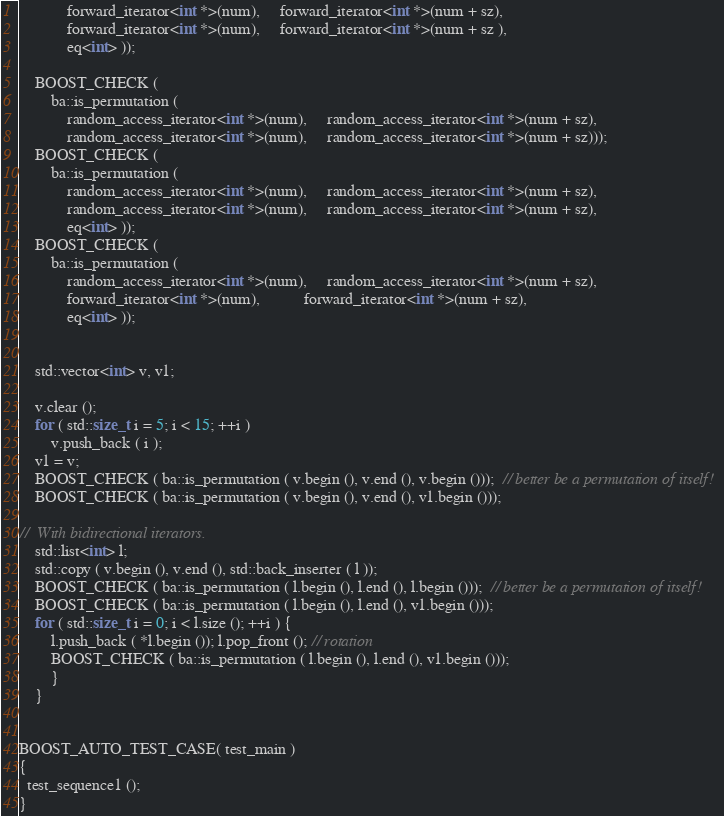Convert code to text. <code><loc_0><loc_0><loc_500><loc_500><_C++_>            forward_iterator<int *>(num),     forward_iterator<int *>(num + sz), 
            forward_iterator<int *>(num),     forward_iterator<int *>(num + sz ),
            eq<int> ));
            
    BOOST_CHECK (
        ba::is_permutation (
            random_access_iterator<int *>(num),     random_access_iterator<int *>(num + sz), 
            random_access_iterator<int *>(num),     random_access_iterator<int *>(num + sz)));
    BOOST_CHECK (
        ba::is_permutation (
            random_access_iterator<int *>(num),     random_access_iterator<int *>(num + sz), 
            random_access_iterator<int *>(num),     random_access_iterator<int *>(num + sz),
            eq<int> ));
    BOOST_CHECK (
        ba::is_permutation (
            random_access_iterator<int *>(num),     random_access_iterator<int *>(num + sz), 
            forward_iterator<int *>(num),           forward_iterator<int *>(num + sz),
            eq<int> ));
    

    std::vector<int> v, v1;
    
    v.clear ();
    for ( std::size_t i = 5; i < 15; ++i )
        v.push_back ( i );
    v1 = v;
    BOOST_CHECK ( ba::is_permutation ( v.begin (), v.end (), v.begin ()));  // better be a permutation of itself!
    BOOST_CHECK ( ba::is_permutation ( v.begin (), v.end (), v1.begin ()));    

//  With bidirectional iterators.
    std::list<int> l;
    std::copy ( v.begin (), v.end (), std::back_inserter ( l ));
    BOOST_CHECK ( ba::is_permutation ( l.begin (), l.end (), l.begin ()));  // better be a permutation of itself!
    BOOST_CHECK ( ba::is_permutation ( l.begin (), l.end (), v1.begin ()));
    for ( std::size_t i = 0; i < l.size (); ++i ) {
        l.push_back ( *l.begin ()); l.pop_front (); // rotation
        BOOST_CHECK ( ba::is_permutation ( l.begin (), l.end (), v1.begin ()));
        }   
    }


BOOST_AUTO_TEST_CASE( test_main )
{
  test_sequence1 ();
}
</code> 